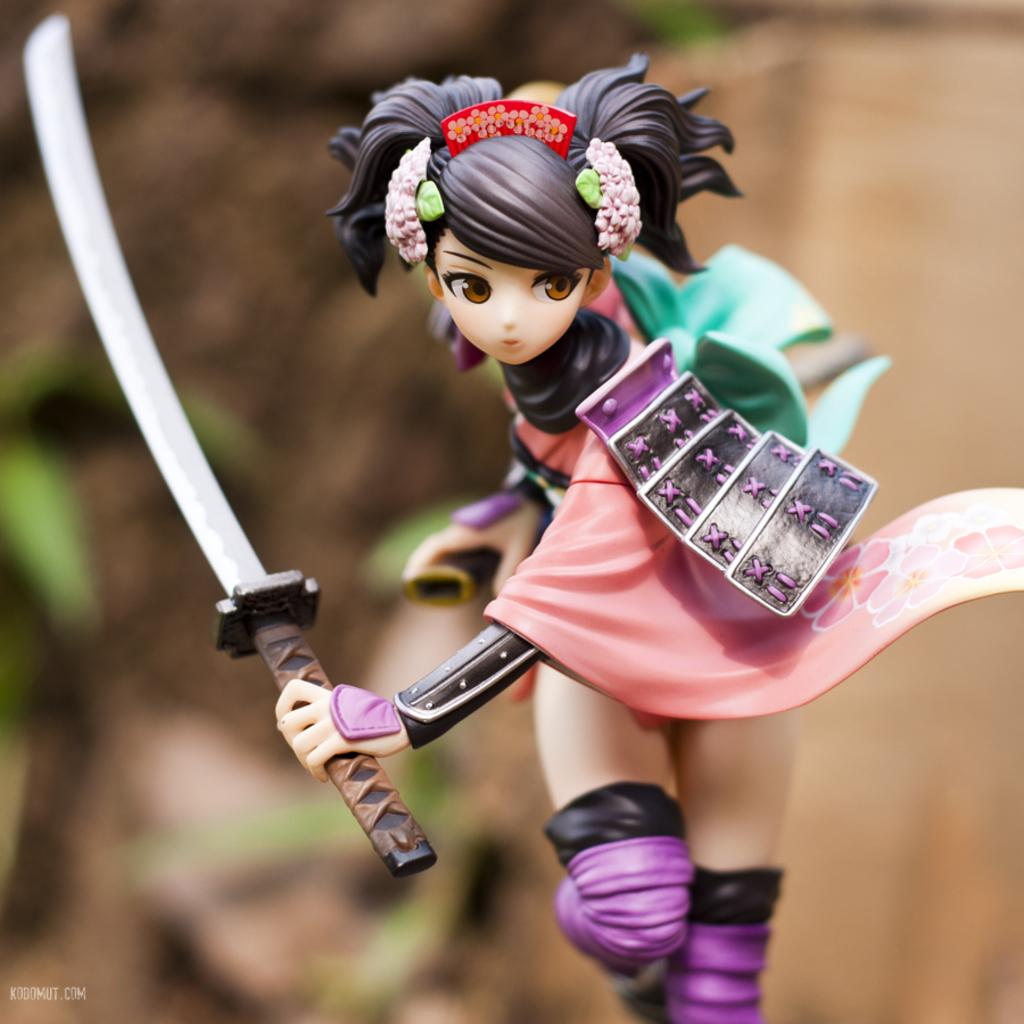What is the main subject of the image? The main subject of the image is a toy girl. What is the toy girl holding in the image? The toy girl is holding a sword in the image. Can you describe the background of the image? The background of the image is blurry. What type of education does the toy girl provide in the image? The image does not show the toy girl providing any education; it only shows her holding a sword. 